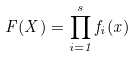<formula> <loc_0><loc_0><loc_500><loc_500>F ( X ) = \prod _ { i = 1 } ^ { s } f _ { i } ( x )</formula> 